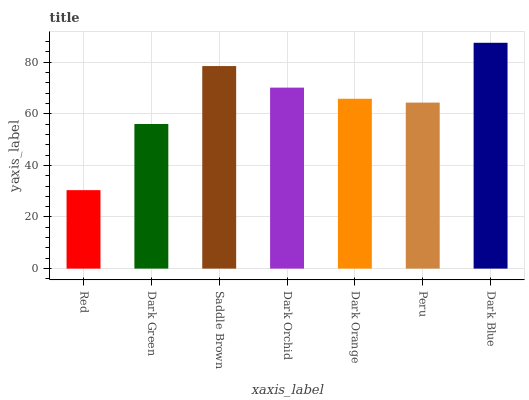Is Red the minimum?
Answer yes or no. Yes. Is Dark Blue the maximum?
Answer yes or no. Yes. Is Dark Green the minimum?
Answer yes or no. No. Is Dark Green the maximum?
Answer yes or no. No. Is Dark Green greater than Red?
Answer yes or no. Yes. Is Red less than Dark Green?
Answer yes or no. Yes. Is Red greater than Dark Green?
Answer yes or no. No. Is Dark Green less than Red?
Answer yes or no. No. Is Dark Orange the high median?
Answer yes or no. Yes. Is Dark Orange the low median?
Answer yes or no. Yes. Is Red the high median?
Answer yes or no. No. Is Red the low median?
Answer yes or no. No. 